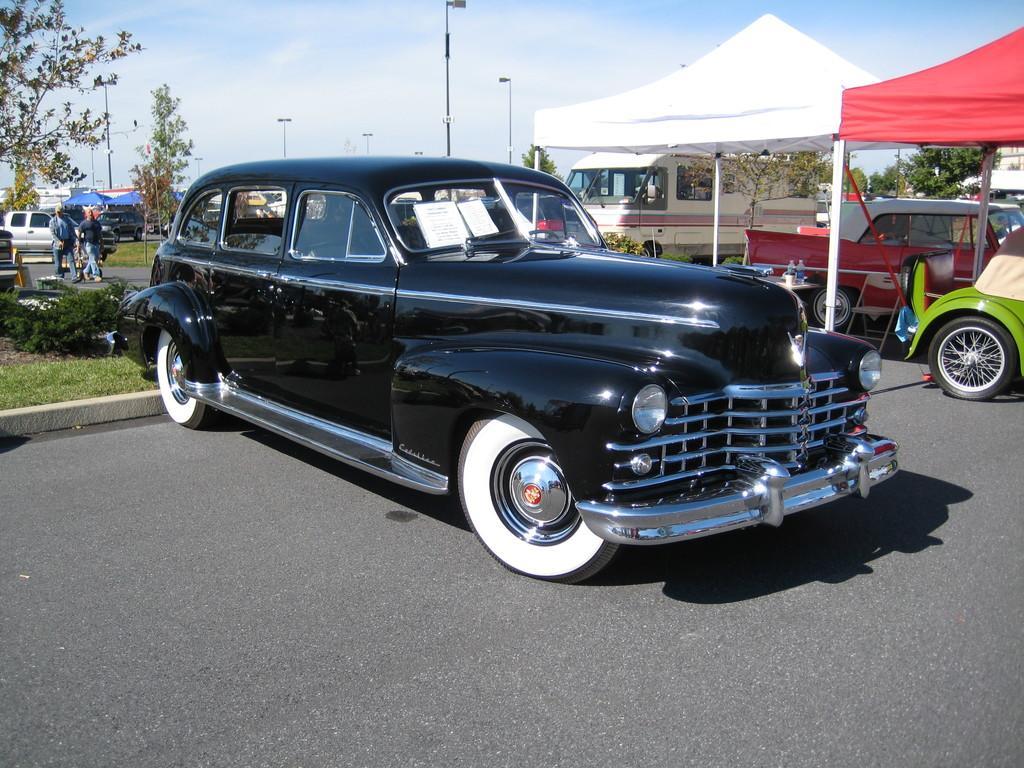Describe this image in one or two sentences. In this image, I can see the cars on the road, canopy tents, trees and street lights. On the left side of the image, there are two people walking. In the background, there is the sky. 